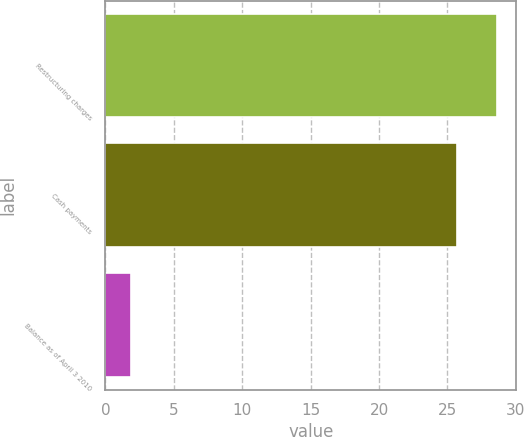<chart> <loc_0><loc_0><loc_500><loc_500><bar_chart><fcel>Restructuring charges<fcel>Cash payments<fcel>Balance as of April 3 2010<nl><fcel>28.6<fcel>25.7<fcel>1.9<nl></chart> 